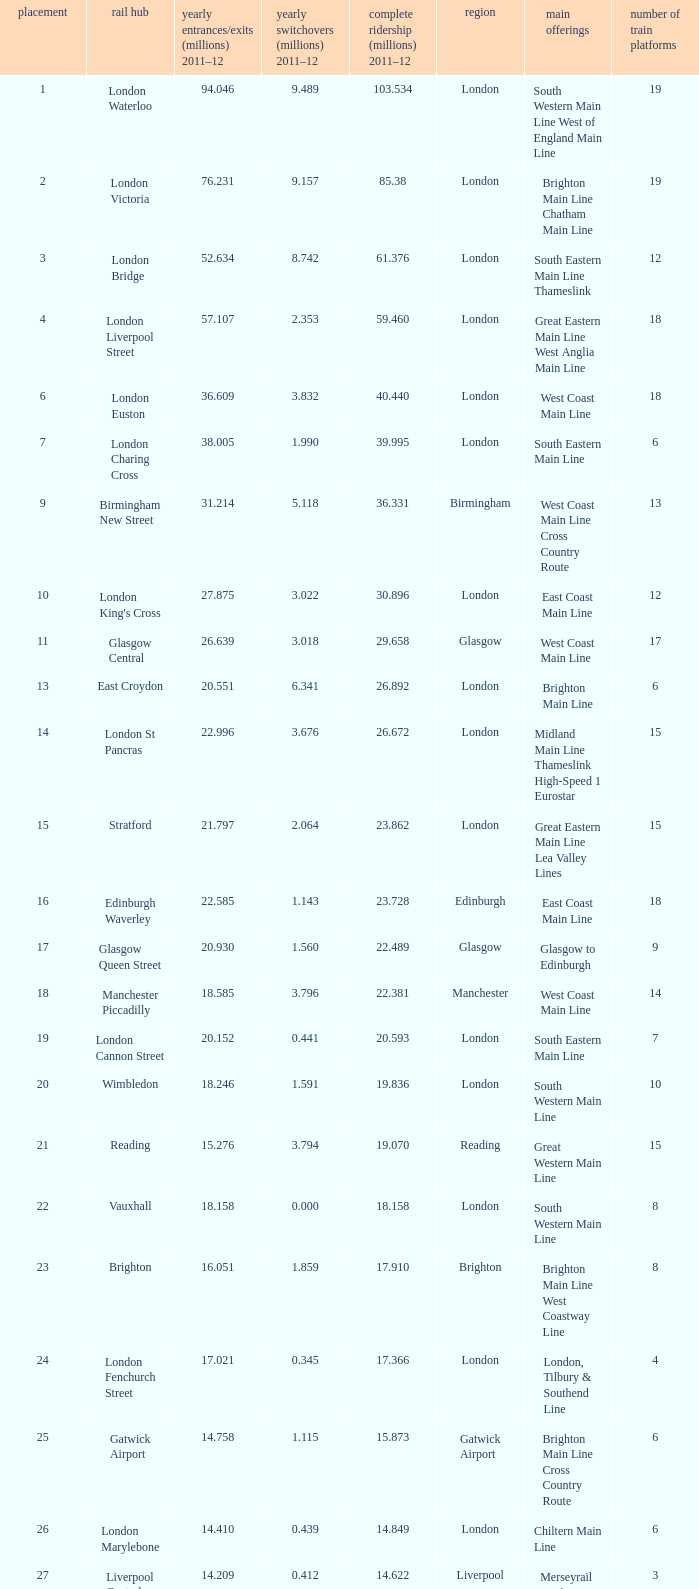What is the main service for the station with 14.849 million passengers 2011-12?  Chiltern Main Line. 